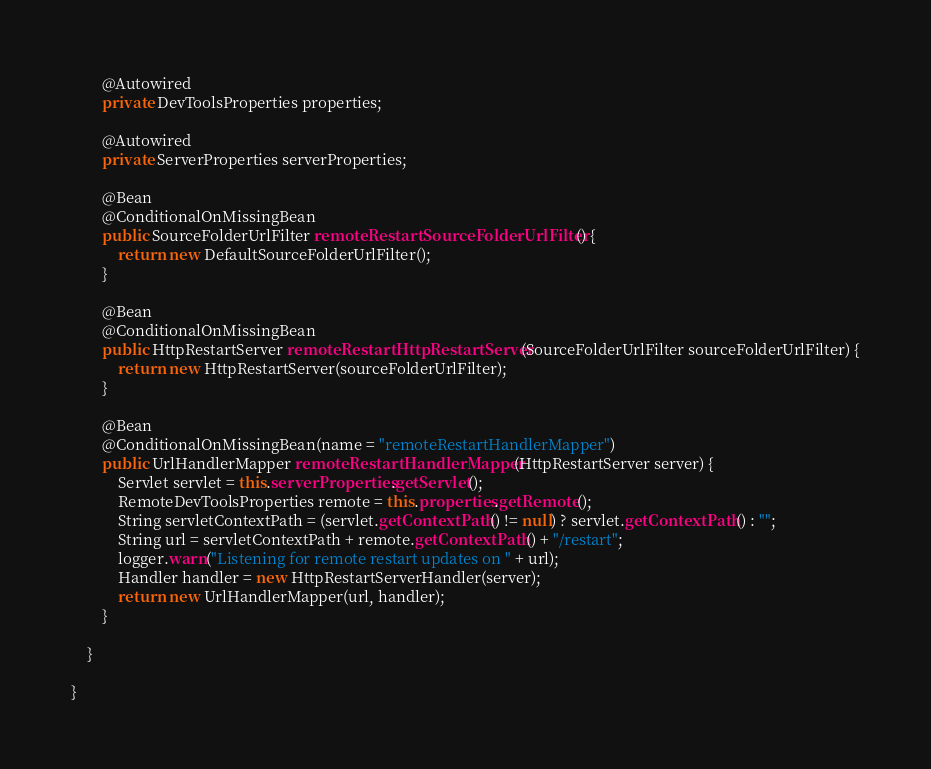<code> <loc_0><loc_0><loc_500><loc_500><_Java_>
		@Autowired
		private DevToolsProperties properties;

		@Autowired
		private ServerProperties serverProperties;

		@Bean
		@ConditionalOnMissingBean
		public SourceFolderUrlFilter remoteRestartSourceFolderUrlFilter() {
			return new DefaultSourceFolderUrlFilter();
		}

		@Bean
		@ConditionalOnMissingBean
		public HttpRestartServer remoteRestartHttpRestartServer(SourceFolderUrlFilter sourceFolderUrlFilter) {
			return new HttpRestartServer(sourceFolderUrlFilter);
		}

		@Bean
		@ConditionalOnMissingBean(name = "remoteRestartHandlerMapper")
		public UrlHandlerMapper remoteRestartHandlerMapper(HttpRestartServer server) {
			Servlet servlet = this.serverProperties.getServlet();
			RemoteDevToolsProperties remote = this.properties.getRemote();
			String servletContextPath = (servlet.getContextPath() != null) ? servlet.getContextPath() : "";
			String url = servletContextPath + remote.getContextPath() + "/restart";
			logger.warn("Listening for remote restart updates on " + url);
			Handler handler = new HttpRestartServerHandler(server);
			return new UrlHandlerMapper(url, handler);
		}

	}

}
</code> 